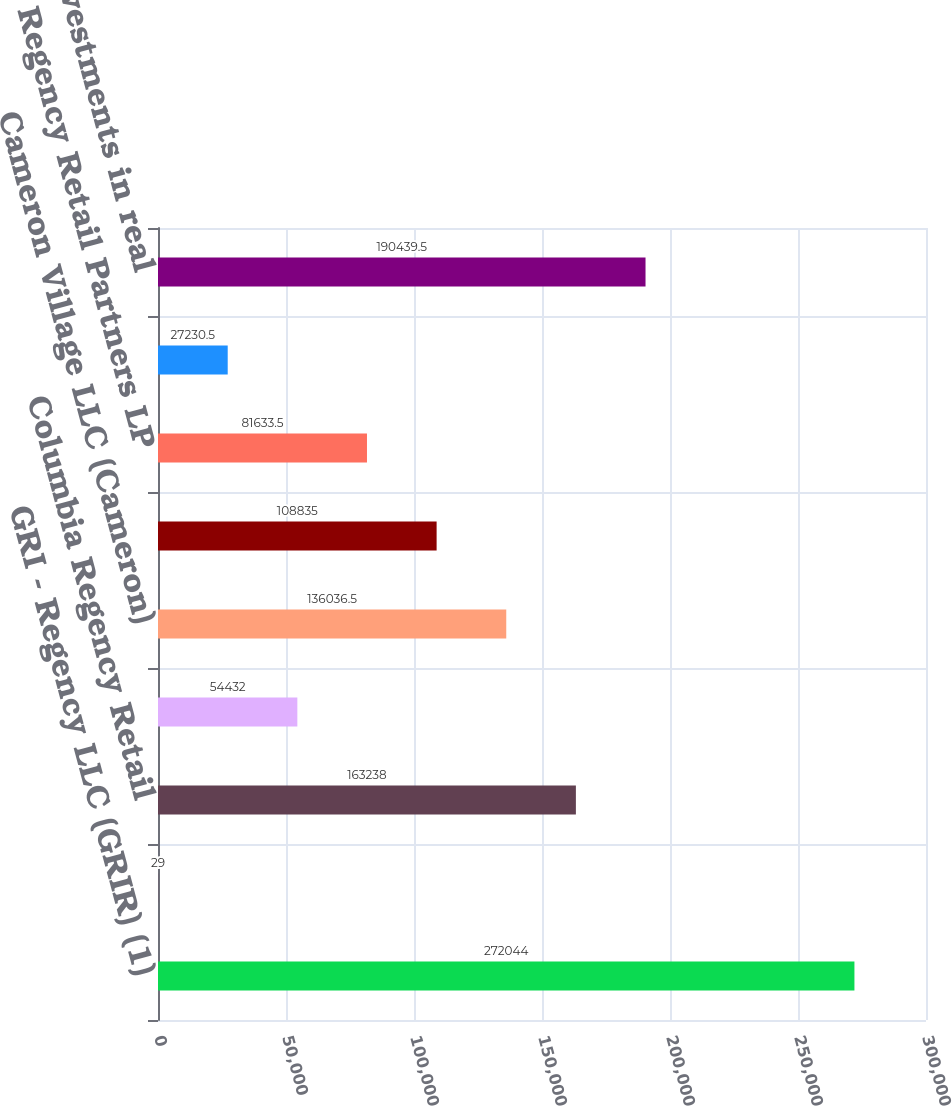<chart> <loc_0><loc_0><loc_500><loc_500><bar_chart><fcel>GRI - Regency LLC (GRIR) (1)<fcel>Macquarie CountryWide-Regency<fcel>Columbia Regency Retail<fcel>Columbia Regency Partners II<fcel>Cameron Village LLC (Cameron)<fcel>RegCal LLC (RegCal) (2)<fcel>Regency Retail Partners LP<fcel>US Regency Retail I LLC (USAA)<fcel>Other investments in real<nl><fcel>272044<fcel>29<fcel>163238<fcel>54432<fcel>136036<fcel>108835<fcel>81633.5<fcel>27230.5<fcel>190440<nl></chart> 